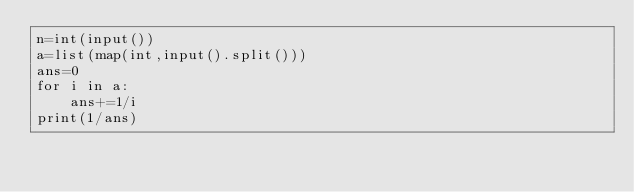<code> <loc_0><loc_0><loc_500><loc_500><_Python_>n=int(input())
a=list(map(int,input().split()))
ans=0
for i in a:
    ans+=1/i
print(1/ans)</code> 